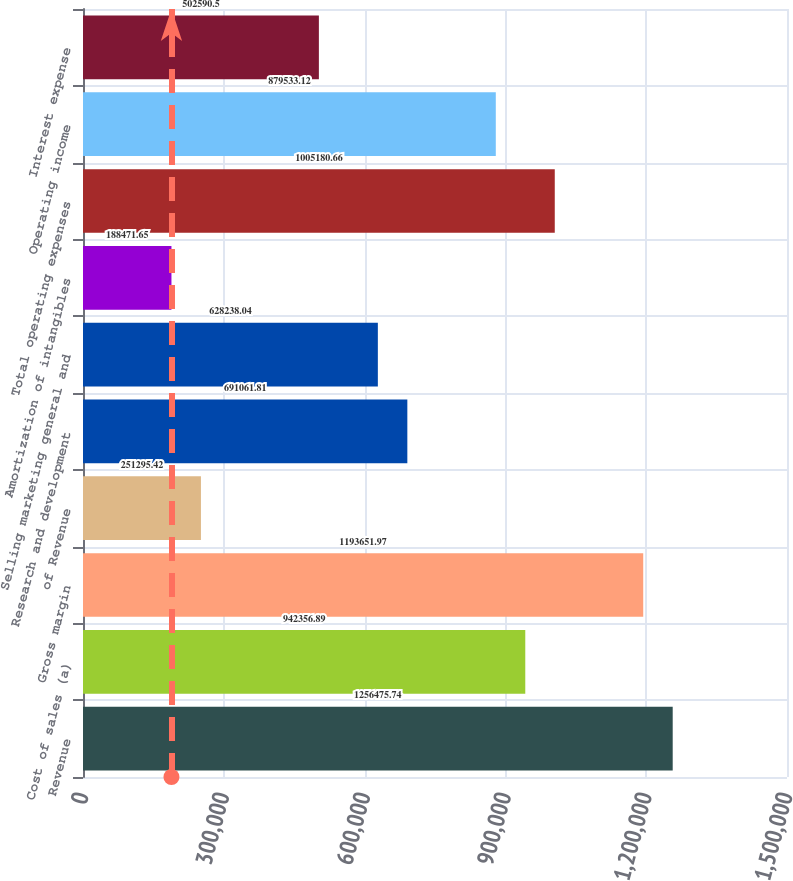Convert chart. <chart><loc_0><loc_0><loc_500><loc_500><bar_chart><fcel>Revenue<fcel>Cost of sales (a)<fcel>Gross margin<fcel>of Revenue<fcel>Research and development<fcel>Selling marketing general and<fcel>Amortization of intangibles<fcel>Total operating expenses<fcel>Operating income<fcel>Interest expense<nl><fcel>1.25648e+06<fcel>942357<fcel>1.19365e+06<fcel>251295<fcel>691062<fcel>628238<fcel>188472<fcel>1.00518e+06<fcel>879533<fcel>502590<nl></chart> 